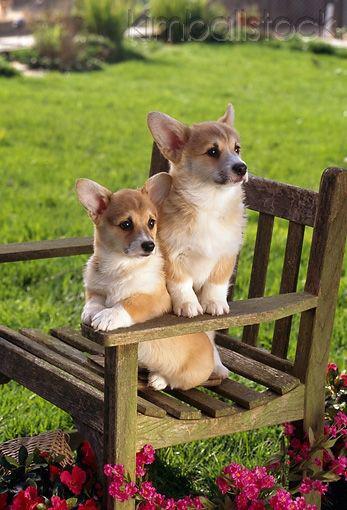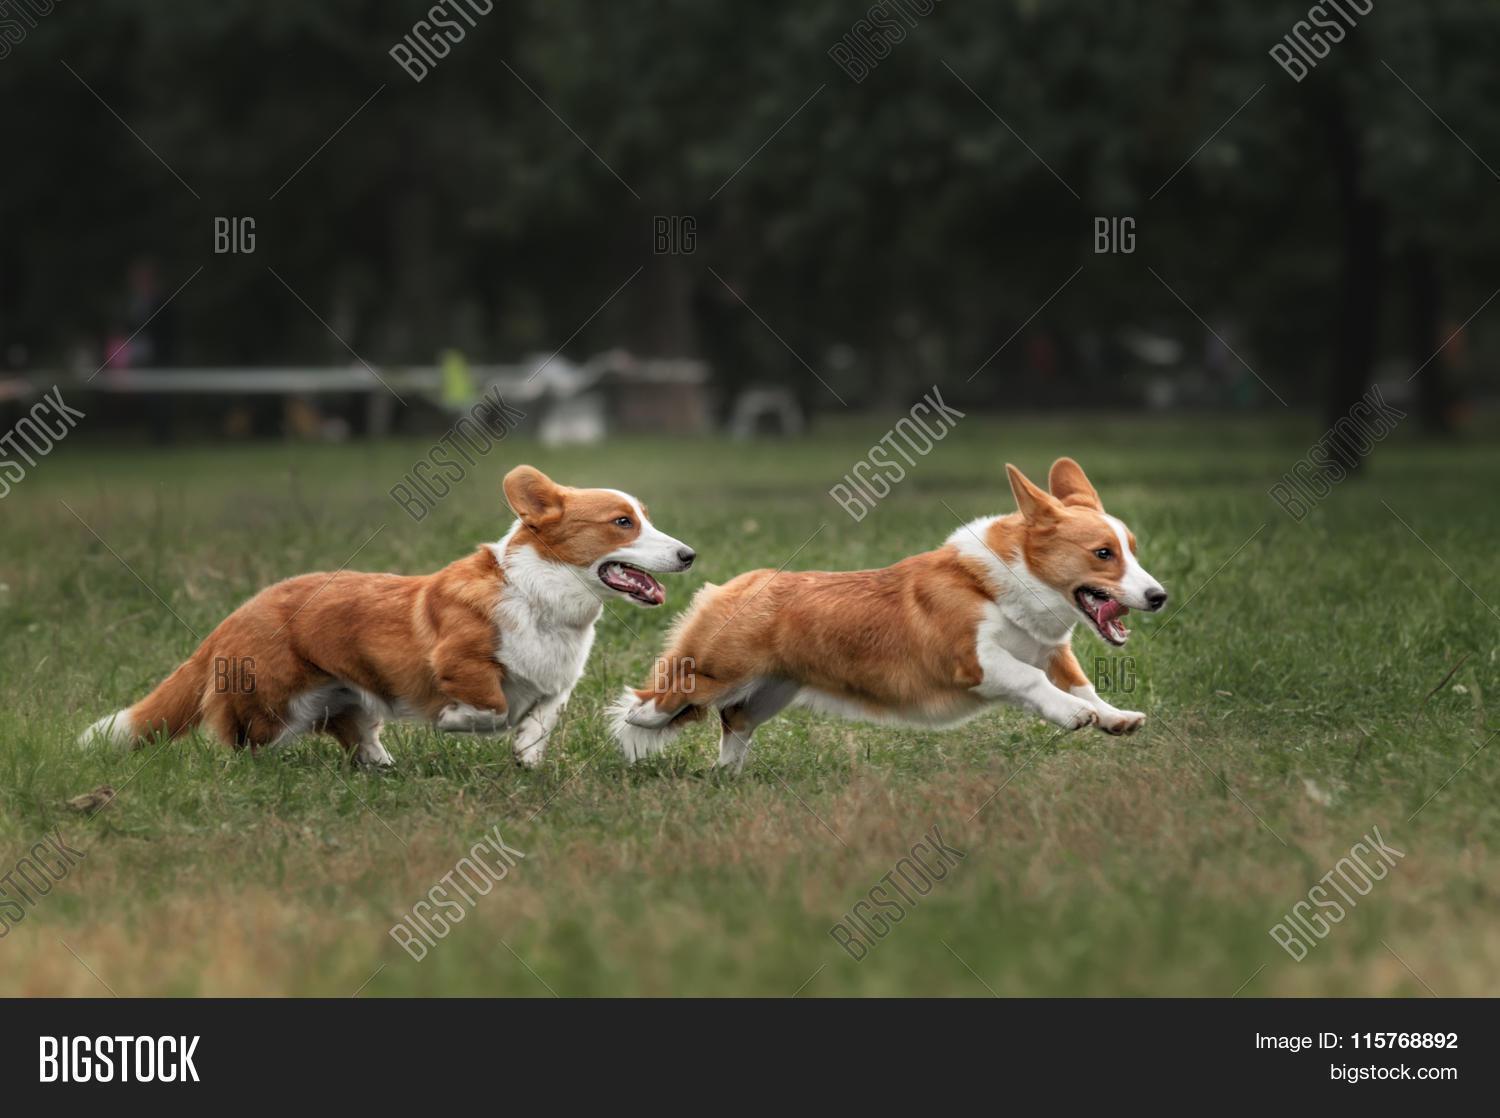The first image is the image on the left, the second image is the image on the right. For the images shown, is this caption "There is a dog in the left image standing on grass." true? Answer yes or no. No. 